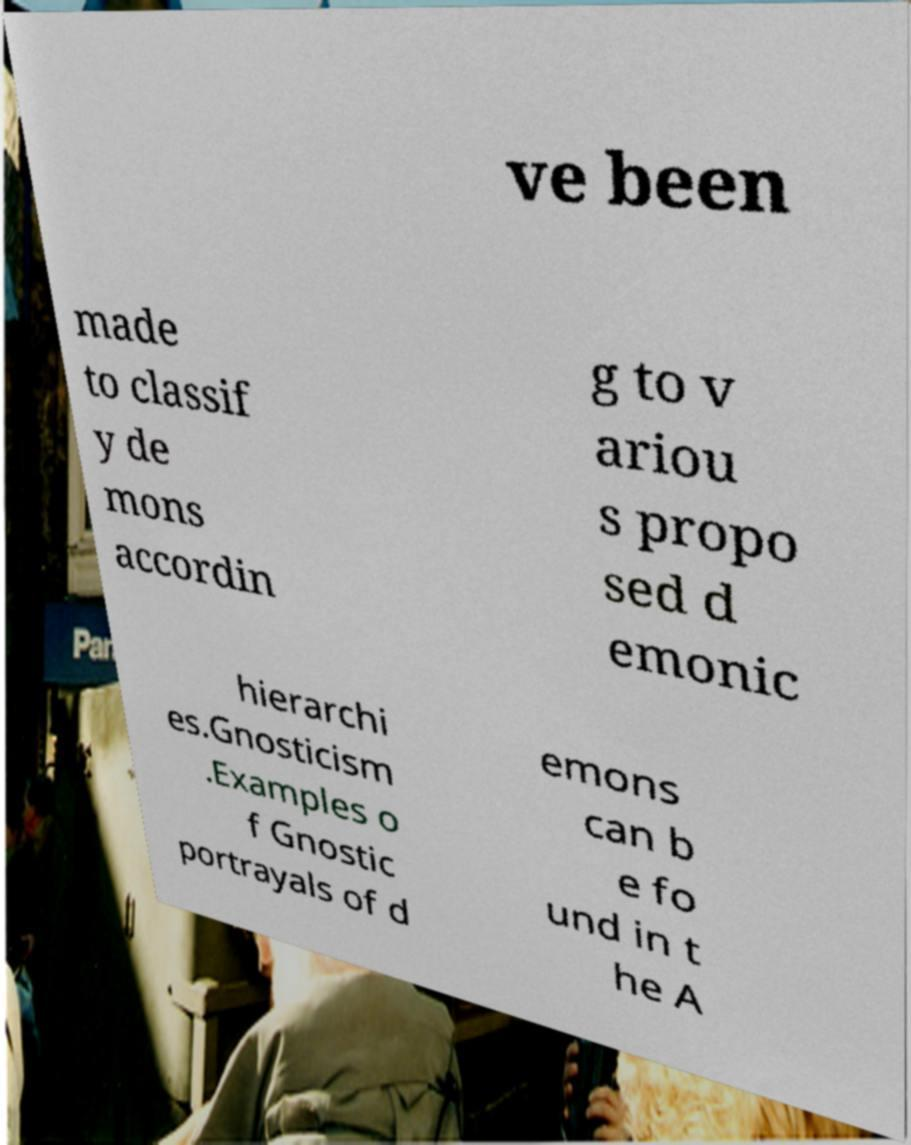Could you extract and type out the text from this image? ve been made to classif y de mons accordin g to v ariou s propo sed d emonic hierarchi es.Gnosticism .Examples o f Gnostic portrayals of d emons can b e fo und in t he A 